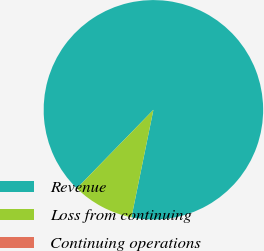Convert chart to OTSL. <chart><loc_0><loc_0><loc_500><loc_500><pie_chart><fcel>Revenue<fcel>Loss from continuing<fcel>Continuing operations<nl><fcel>90.91%<fcel>9.09%<fcel>0.0%<nl></chart> 